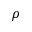Convert formula to latex. <formula><loc_0><loc_0><loc_500><loc_500>\rho</formula> 